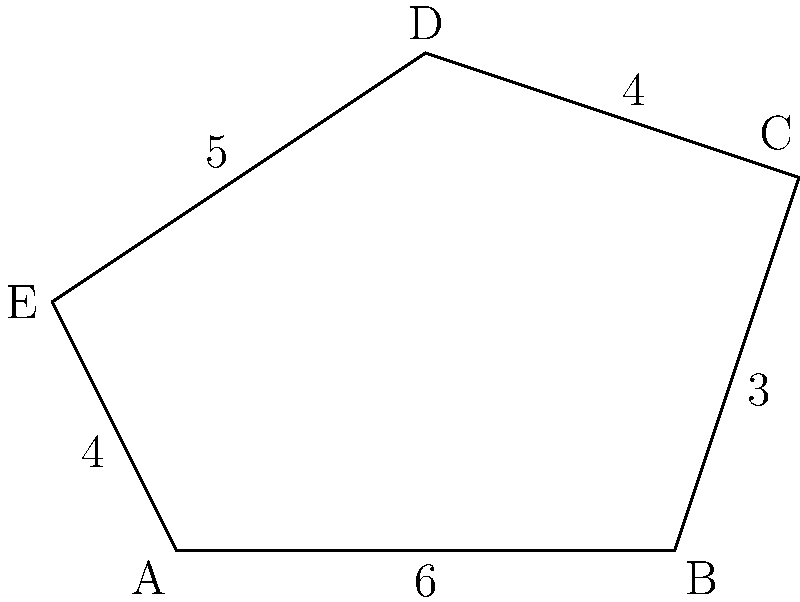In a tale of ancient Indian architecture, a writer describes an irregularly shaped courtyard in a palace. The courtyard is represented by the pentagon ABCDE in the figure above. Given that the lengths of the sides are AB = 6 units, BC = 3 units, CD = 4 units, DE = 5 units, and EA = 4 units, calculate the perimeter of this courtyard. How might this unique shape inspire a story about the palace's history? To calculate the perimeter of the irregular pentagon ABCDE, we need to sum up the lengths of all its sides. Let's break it down step by step:

1. Side AB = 6 units
2. Side BC = 3 units
3. Side CD = 4 units
4. Side DE = 5 units
5. Side EA = 4 units

Now, we can calculate the perimeter by adding all these lengths:

$$\text{Perimeter} = AB + BC + CD + DE + EA$$
$$\text{Perimeter} = 6 + 3 + 4 + 5 + 4$$
$$\text{Perimeter} = 22 \text{ units}$$

This unique shape could inspire a story about the palace's history by suggesting that each side of the courtyard represents a different era or reign in the palace's past. The varying lengths could symbolize the different durations or impacts of these periods, with longer sides representing more significant or longer-lasting influences on the palace's legacy.
Answer: 22 units 